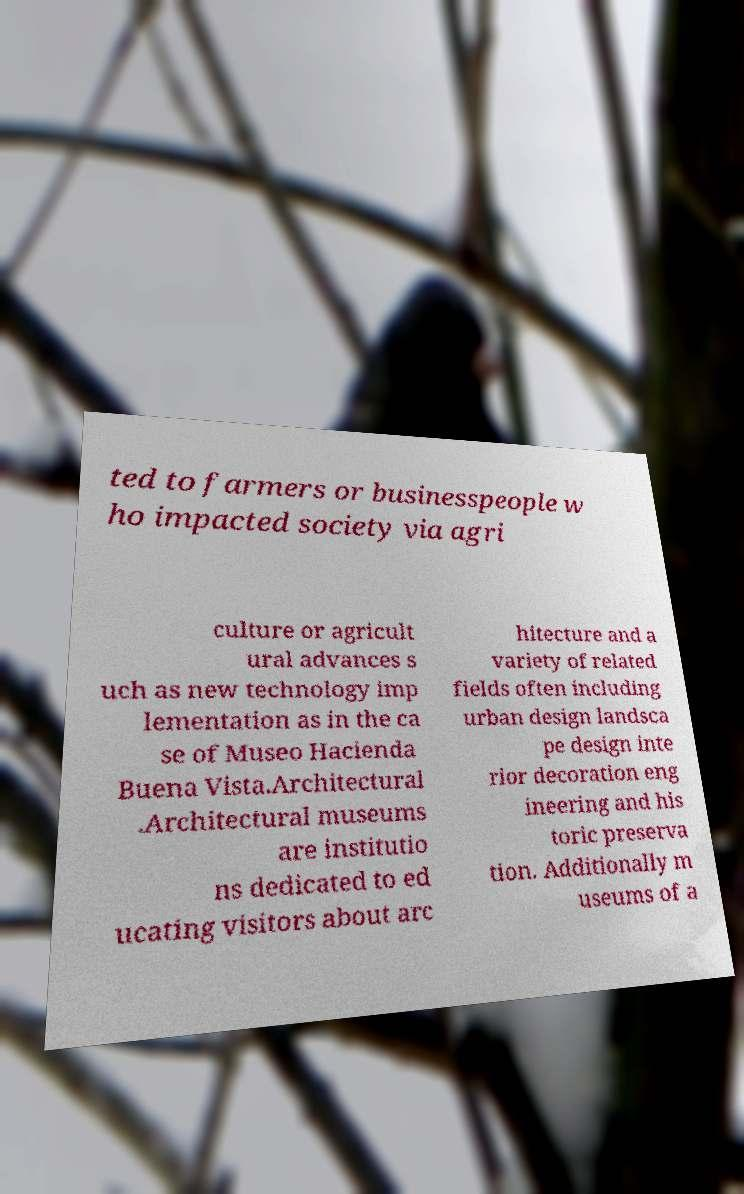What messages or text are displayed in this image? I need them in a readable, typed format. ted to farmers or businesspeople w ho impacted society via agri culture or agricult ural advances s uch as new technology imp lementation as in the ca se of Museo Hacienda Buena Vista.Architectural .Architectural museums are institutio ns dedicated to ed ucating visitors about arc hitecture and a variety of related fields often including urban design landsca pe design inte rior decoration eng ineering and his toric preserva tion. Additionally m useums of a 